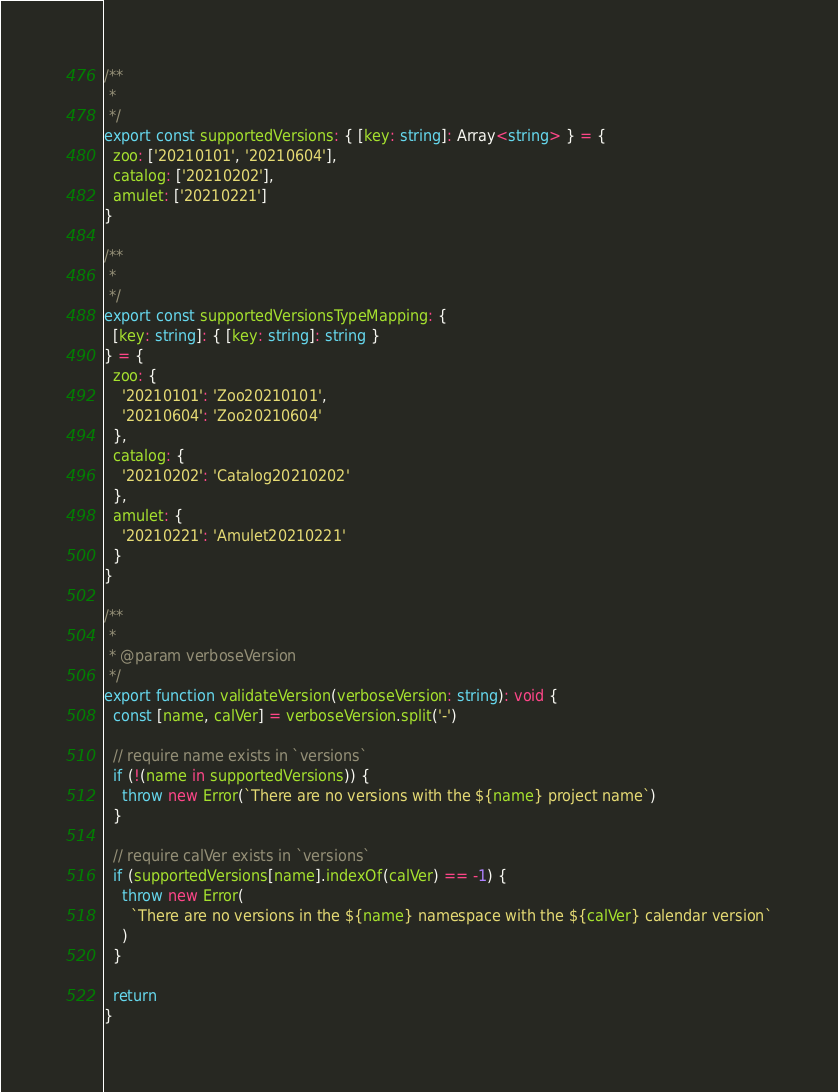Convert code to text. <code><loc_0><loc_0><loc_500><loc_500><_TypeScript_>/**
 *
 */
export const supportedVersions: { [key: string]: Array<string> } = {
  zoo: ['20210101', '20210604'],
  catalog: ['20210202'],
  amulet: ['20210221']
}

/**
 *
 */
export const supportedVersionsTypeMapping: {
  [key: string]: { [key: string]: string }
} = {
  zoo: {
    '20210101': 'Zoo20210101',
    '20210604': 'Zoo20210604'
  },
  catalog: {
    '20210202': 'Catalog20210202'
  },
  amulet: {
    '20210221': 'Amulet20210221'
  }
}

/**
 *
 * @param verboseVersion
 */
export function validateVersion(verboseVersion: string): void {
  const [name, calVer] = verboseVersion.split('-')

  // require name exists in `versions`
  if (!(name in supportedVersions)) {
    throw new Error(`There are no versions with the ${name} project name`)
  }

  // require calVer exists in `versions`
  if (supportedVersions[name].indexOf(calVer) == -1) {
    throw new Error(
      `There are no versions in the ${name} namespace with the ${calVer} calendar version`
    )
  }

  return
}
</code> 